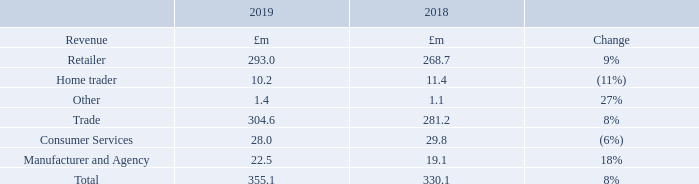Revenue
In 2019, we saw another strong year of revenue growth at 8%, climbing to £355.1m (2018: £330.1m), predominantly through Trade revenue, and more specifically Retailer revenue, as our core business continued to grow.
Trade revenue – comprising Retailers, Home Traders and other revenue – increased by 8% to £304.6m (2018: £281.2m). Retailer revenue grew 9% to £293.0m (2018: £268.7m), driven by the launch of new products, our annual pricing event and further penetration of higher yielding advertising packages. Average Revenue Per Retailer (‘ARPR’) improved by £149 to £1,844 per month (2018: £1,695). Average retailer forecourts were stable, with a marginal increase in the year to 13,240 (2018: 13,213). Trade revenue – comprising Retailers, Home Traders and other revenue – increased by 8% to £304.6m (2018: £281.2m). Retailer revenue grew 9% to £293.0m (2018: £268.7m), driven by the launch of new products, our annual pricing event and further penetration of higher yielding advertising packages. Average Revenue Per Retailer (‘ARPR’) improved by £149 to £1,844 per month (2018: £1,695). Average retailer forecourts were stable, with a marginal increase in the year to 13,240 (2018: 13,213).
ARPR growth of £149 per month was broken down as follows into our three levers: price, stock and product.
——Price: Our price lever contributed £50 (2018: £43) and 34% (2018: 29%) of total ARPR growth. We executed our annual event for the vast majority of customers on 1 April 2018 which included a like-for-like price increase.
——Stock: A small contraction in stock had a negative effect on ARPR growth of £22 (2018: positive effect of £20) and was -15% (2018: +13%) of total ARPR growth. A reduction in the number of new cars registered, lower volumes of preregistration and some consumer uncertainty led to a lack of used car supply in the market during the first half of the year. Retailer stock has seen some level of recovery through the second half of the year although the market is still challenging.
——Product: Our product lever contributed £121 (2018: £86) and 81% (2018: 58%) of total ARPR growth. Our annual event allowed us to introduce two new products, stock exports and profile pages, into all package levels and we also monetised our Dealer Finance product following a trial period. Since 1 April 2018, over 5,000 retailers have opted to pay for the opportunity to advertise their finance offers against their cars, representing 70% of all eligible retailers. In addition, the penetration of our higher yielding Advanced and Premium advertising packages has continued to grow as retailers recognise the value of receiving greater prominence within our search listings. At the end of March, 19% of retailer cars advertised were on one of these levels (March 2018: 12%). There was also a small contribution from our Managing products, which despite re-platforming and continued development in the year, still saw growth to 3,200 customers (2018: 3,000).
Revenue £355.1m +8% (2018: £330.1m)
Operating profit £243.7m +10% (2018 restated: £221.3m)
Cash generated from operations £258.5m +13% (2018 restated: £228.4m)
Cash returned to shareholders £151.1m (2018: £148.4m)
What was the percentage change in revenue growth in 2019 from 2018? 8%. What was the amount of Trade revenue in 2019? £304.6m. What were the components under Trade revenue? Retailer, home trader, other. In which year was Consumer Services larger? 29.8>28.0
Answer: 2018. What was the change in total revenue in 2019 from 2018?
Answer scale should be: million. 355.1-330.1
Answer: 25. What was the average total revenue in 2018 and 2019?
Answer scale should be: million. (355.1+330.1)/2
Answer: 342.6. 